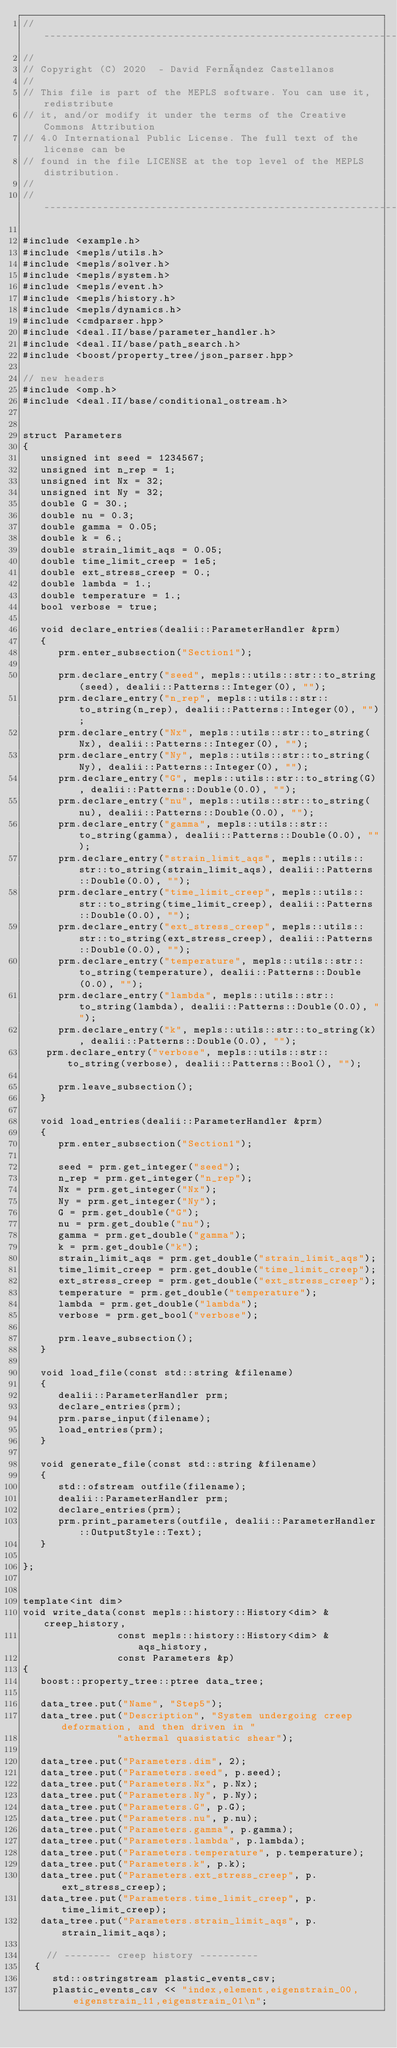<code> <loc_0><loc_0><loc_500><loc_500><_C++_>// -----------------------------------------------------------------------
//
// Copyright (C) 2020  - David Fernández Castellanos
//
// This file is part of the MEPLS software. You can use it, redistribute
// it, and/or modify it under the terms of the Creative Commons Attribution
// 4.0 International Public License. The full text of the license can be
// found in the file LICENSE at the top level of the MEPLS distribution.
//
// -----------------------------------------------------------------------

#include <example.h>
#include <mepls/utils.h>
#include <mepls/solver.h>
#include <mepls/system.h>
#include <mepls/event.h>
#include <mepls/history.h>
#include <mepls/dynamics.h>
#include <cmdparser.hpp>
#include <deal.II/base/parameter_handler.h>
#include <deal.II/base/path_search.h>
#include <boost/property_tree/json_parser.hpp>

// new headers
#include <omp.h>
#include <deal.II/base/conditional_ostream.h>


struct Parameters
{
   unsigned int seed = 1234567;
   unsigned int n_rep = 1;
   unsigned int Nx = 32;
   unsigned int Ny = 32;
   double G = 30.;
   double nu = 0.3;
   double gamma = 0.05;
   double k = 6.;
   double strain_limit_aqs = 0.05;
   double time_limit_creep = 1e5;
   double ext_stress_creep = 0.;
   double lambda = 1.;
   double temperature = 1.;
   bool verbose = true;

   void declare_entries(dealii::ParameterHandler &prm)
   {
      prm.enter_subsection("Section1");

      prm.declare_entry("seed", mepls::utils::str::to_string(seed), dealii::Patterns::Integer(0), "");
      prm.declare_entry("n_rep", mepls::utils::str::to_string(n_rep), dealii::Patterns::Integer(0), "");
      prm.declare_entry("Nx", mepls::utils::str::to_string(Nx), dealii::Patterns::Integer(0), "");
      prm.declare_entry("Ny", mepls::utils::str::to_string(Ny), dealii::Patterns::Integer(0), "");
      prm.declare_entry("G", mepls::utils::str::to_string(G), dealii::Patterns::Double(0.0), "");
      prm.declare_entry("nu", mepls::utils::str::to_string(nu), dealii::Patterns::Double(0.0), "");
      prm.declare_entry("gamma", mepls::utils::str::to_string(gamma), dealii::Patterns::Double(0.0), "");
      prm.declare_entry("strain_limit_aqs", mepls::utils::str::to_string(strain_limit_aqs), dealii::Patterns::Double(0.0), "");
      prm.declare_entry("time_limit_creep", mepls::utils::str::to_string(time_limit_creep), dealii::Patterns::Double(0.0), "");
      prm.declare_entry("ext_stress_creep", mepls::utils::str::to_string(ext_stress_creep), dealii::Patterns::Double(0.0), "");
      prm.declare_entry("temperature", mepls::utils::str::to_string(temperature), dealii::Patterns::Double(0.0), "");
      prm.declare_entry("lambda", mepls::utils::str::to_string(lambda), dealii::Patterns::Double(0.0), "");
      prm.declare_entry("k", mepls::utils::str::to_string(k), dealii::Patterns::Double(0.0), "");
	  prm.declare_entry("verbose", mepls::utils::str::to_string(verbose), dealii::Patterns::Bool(), "");

      prm.leave_subsection();
   }

   void load_entries(dealii::ParameterHandler &prm)
   {
      prm.enter_subsection("Section1");

      seed = prm.get_integer("seed");
      n_rep = prm.get_integer("n_rep");
      Nx = prm.get_integer("Nx");
      Ny = prm.get_integer("Ny");
      G = prm.get_double("G");
      nu = prm.get_double("nu");
      gamma = prm.get_double("gamma");
      k = prm.get_double("k");
      strain_limit_aqs = prm.get_double("strain_limit_aqs");
      time_limit_creep = prm.get_double("time_limit_creep");
      ext_stress_creep = prm.get_double("ext_stress_creep");
      temperature = prm.get_double("temperature");
      lambda = prm.get_double("lambda");
      verbose = prm.get_bool("verbose");

      prm.leave_subsection();
   }

   void load_file(const std::string &filename)
   {
      dealii::ParameterHandler prm;
      declare_entries(prm);
      prm.parse_input(filename);
      load_entries(prm);
   }

   void generate_file(const std::string &filename)
   {
      std::ofstream outfile(filename);
      dealii::ParameterHandler prm;
      declare_entries(prm);
      prm.print_parameters(outfile, dealii::ParameterHandler::OutputStyle::Text);
   }

};


template<int dim>
void write_data(const mepls::history::History<dim> &creep_history,
                const mepls::history::History<dim> &aqs_history,
                const Parameters &p)
{
   boost::property_tree::ptree data_tree;

   data_tree.put("Name", "Step5");
   data_tree.put("Description", "System undergoing creep deformation, and then driven in "
								"athermal quasistatic shear");

   data_tree.put("Parameters.dim", 2);
   data_tree.put("Parameters.seed", p.seed);
   data_tree.put("Parameters.Nx", p.Nx);
   data_tree.put("Parameters.Ny", p.Ny);
   data_tree.put("Parameters.G", p.G);
   data_tree.put("Parameters.nu", p.nu);
   data_tree.put("Parameters.gamma", p.gamma);
   data_tree.put("Parameters.lambda", p.lambda);
   data_tree.put("Parameters.temperature", p.temperature);
   data_tree.put("Parameters.k", p.k);
   data_tree.put("Parameters.ext_stress_creep", p.ext_stress_creep);
   data_tree.put("Parameters.time_limit_creep", p.time_limit_creep);
   data_tree.put("Parameters.strain_limit_aqs", p.strain_limit_aqs);

   	// -------- creep history ----------
	{
	   std::ostringstream plastic_events_csv;
	   plastic_events_csv << "index,element,eigenstrain_00,eigenstrain_11,eigenstrain_01\n";</code> 